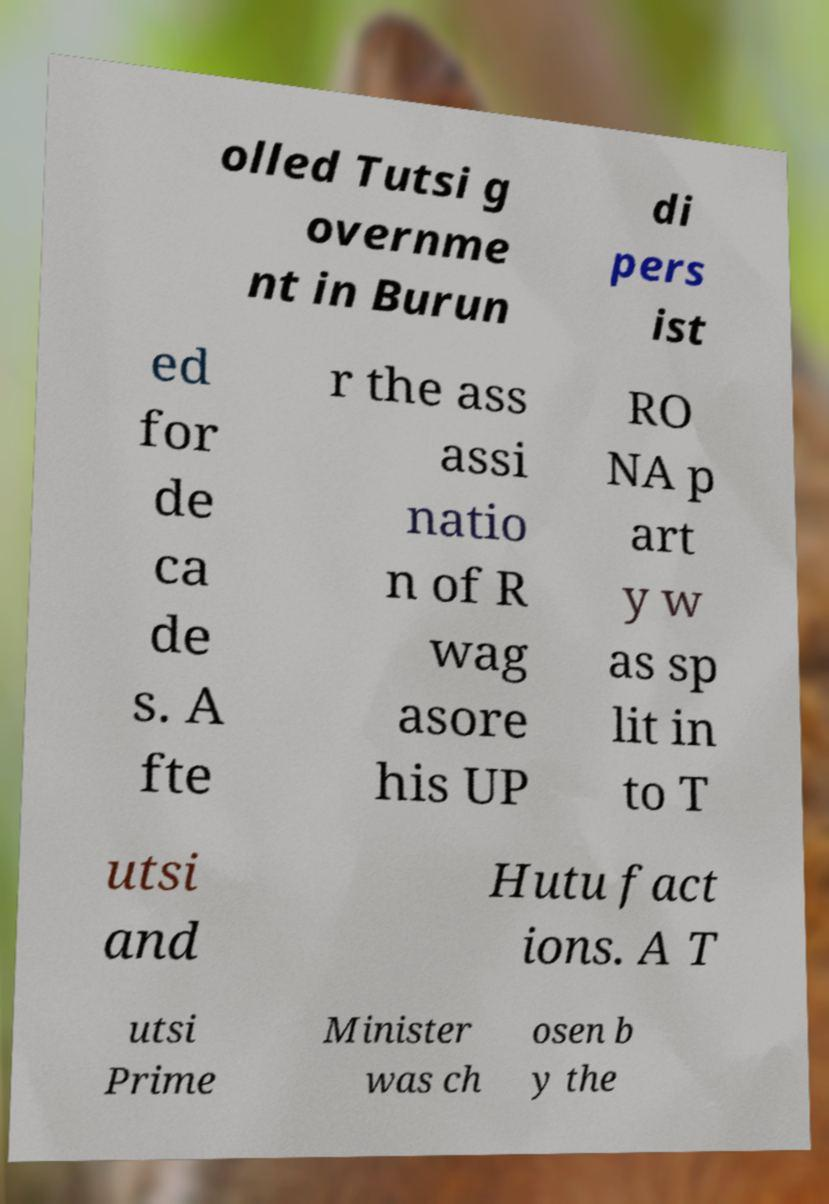For documentation purposes, I need the text within this image transcribed. Could you provide that? olled Tutsi g overnme nt in Burun di pers ist ed for de ca de s. A fte r the ass assi natio n of R wag asore his UP RO NA p art y w as sp lit in to T utsi and Hutu fact ions. A T utsi Prime Minister was ch osen b y the 